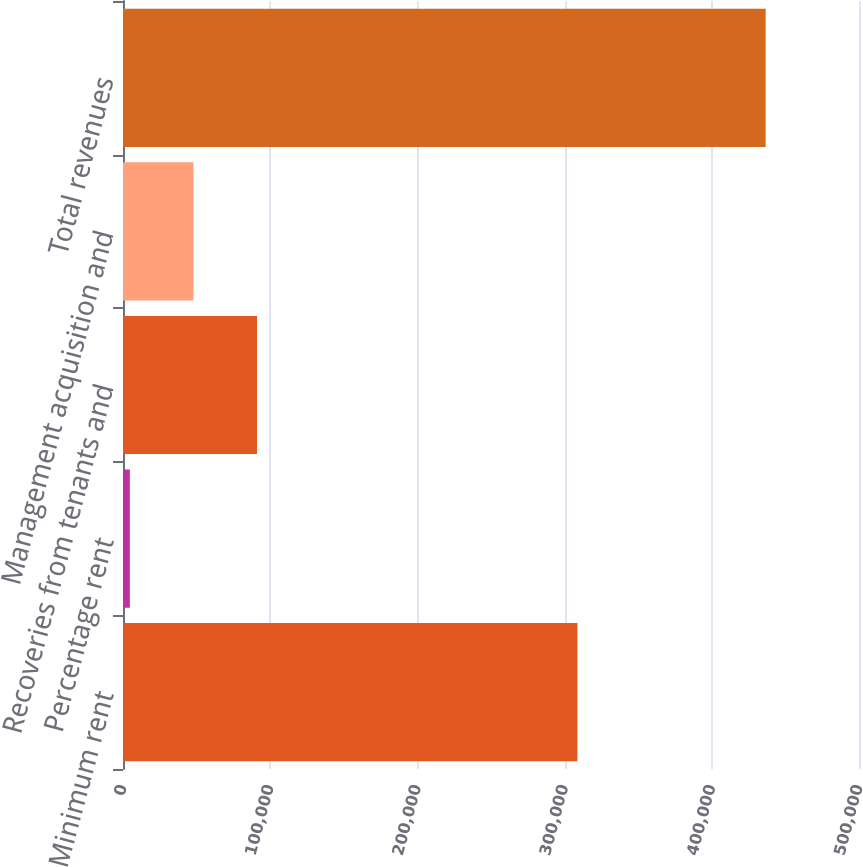Convert chart to OTSL. <chart><loc_0><loc_0><loc_500><loc_500><bar_chart><fcel>Minimum rent<fcel>Percentage rent<fcel>Recoveries from tenants and<fcel>Management acquisition and<fcel>Total revenues<nl><fcel>308720<fcel>4661<fcel>91045.2<fcel>47853.1<fcel>436582<nl></chart> 